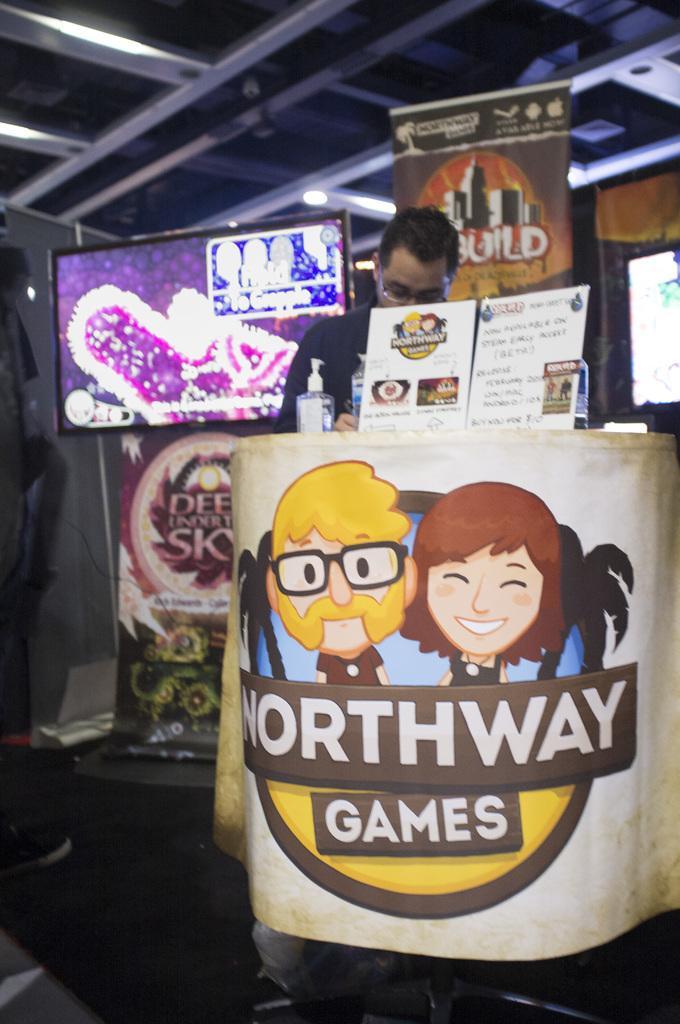How would you summarize this image in a sentence or two? In the center of the image we can see one person standing and he is holding some object and he is wearing glasses. In front of him, there is a table. On the table, we can see one spray bottle, water bottles, banners and a few other objects. On the banners, we can see two cartoon images and some text. In the background there is a wall, screens, banners, one table and a few other objects. 